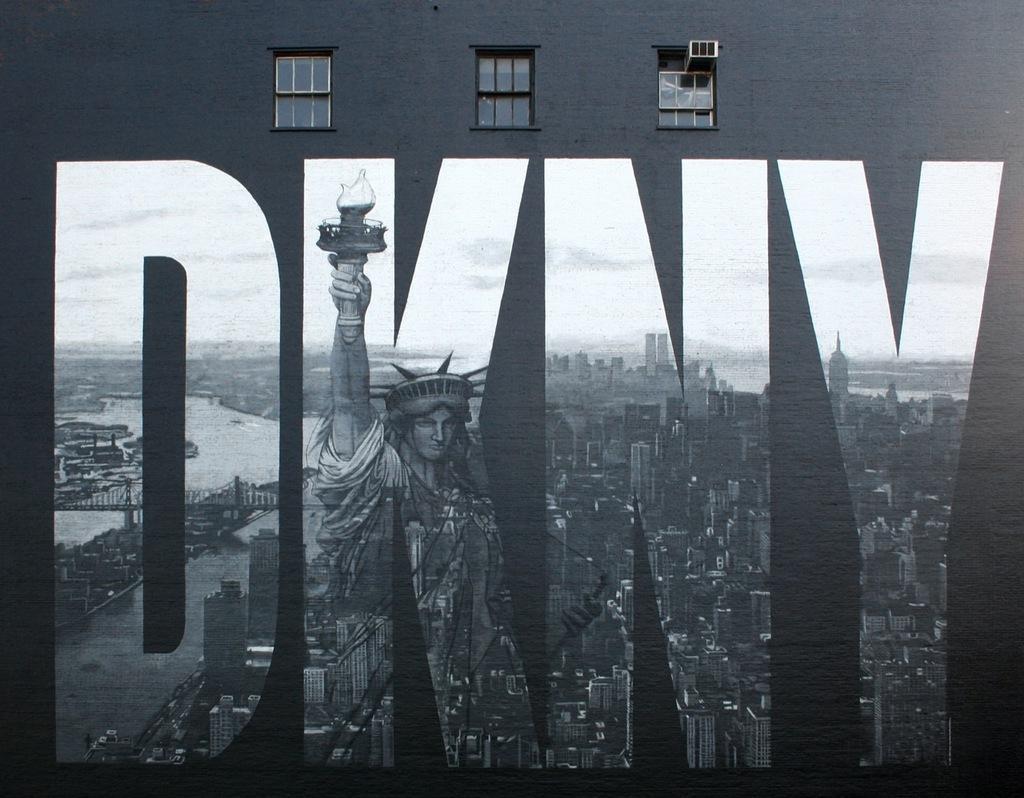Please provide a concise description of this image. In this image, we can see a wall with windows and painting. In this painting, we can see a statue, few buildings, bridge and sky. 